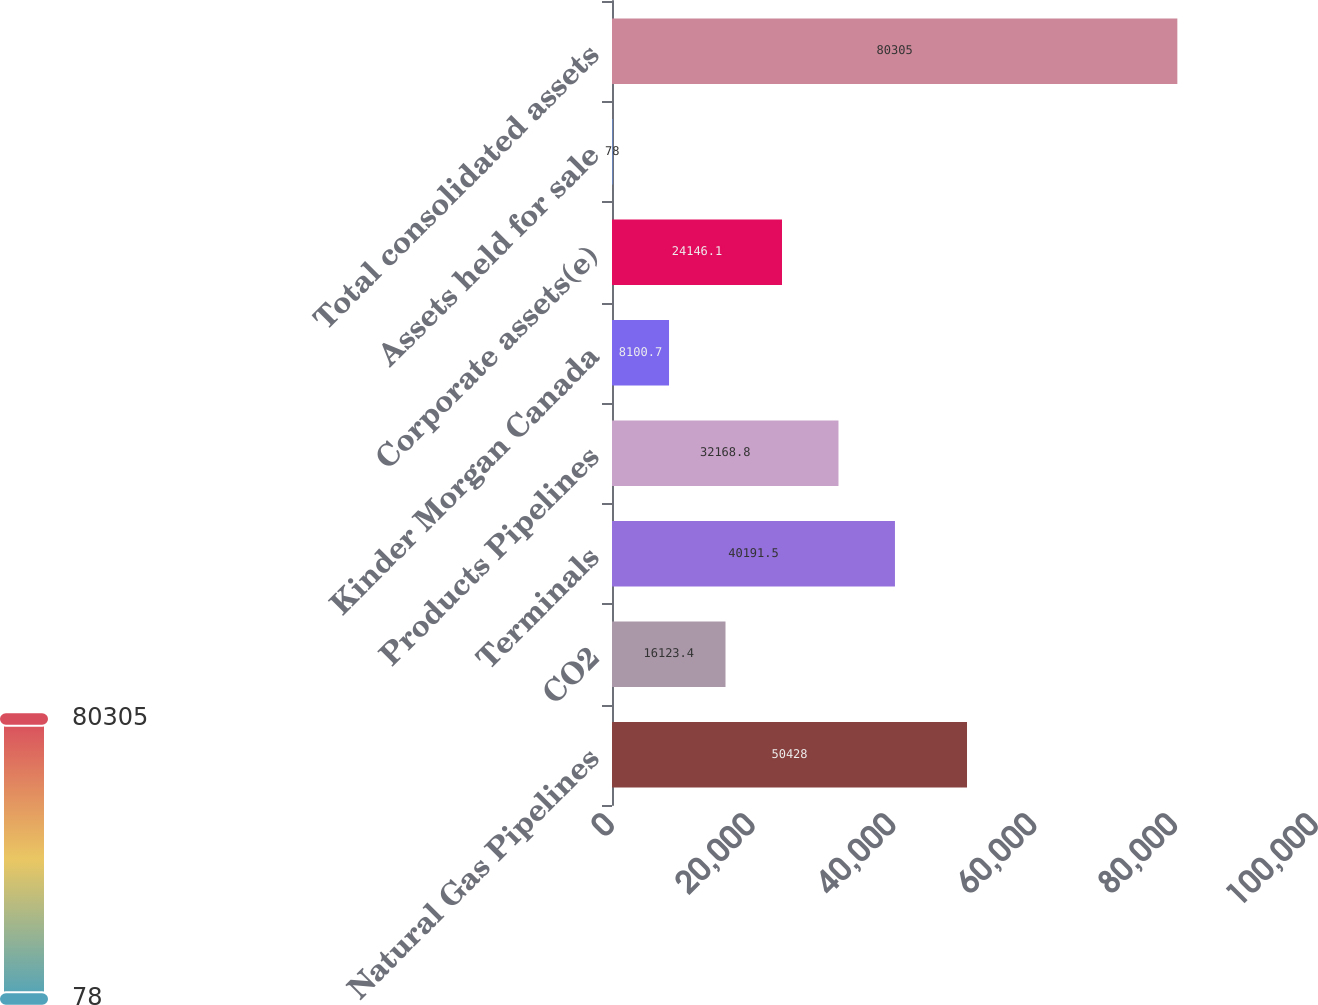Convert chart. <chart><loc_0><loc_0><loc_500><loc_500><bar_chart><fcel>Natural Gas Pipelines<fcel>CO2<fcel>Terminals<fcel>Products Pipelines<fcel>Kinder Morgan Canada<fcel>Corporate assets(e)<fcel>Assets held for sale<fcel>Total consolidated assets<nl><fcel>50428<fcel>16123.4<fcel>40191.5<fcel>32168.8<fcel>8100.7<fcel>24146.1<fcel>78<fcel>80305<nl></chart> 